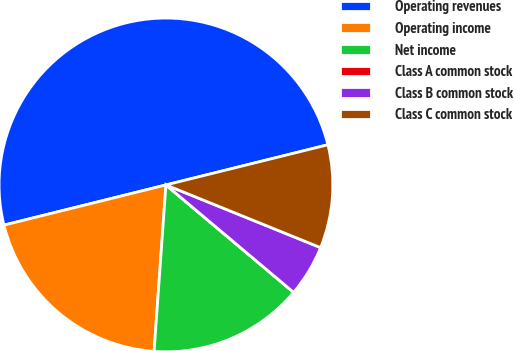Convert chart to OTSL. <chart><loc_0><loc_0><loc_500><loc_500><pie_chart><fcel>Operating revenues<fcel>Operating income<fcel>Net income<fcel>Class A common stock<fcel>Class B common stock<fcel>Class C common stock<nl><fcel>50.0%<fcel>20.0%<fcel>15.0%<fcel>0.0%<fcel>5.0%<fcel>10.0%<nl></chart> 